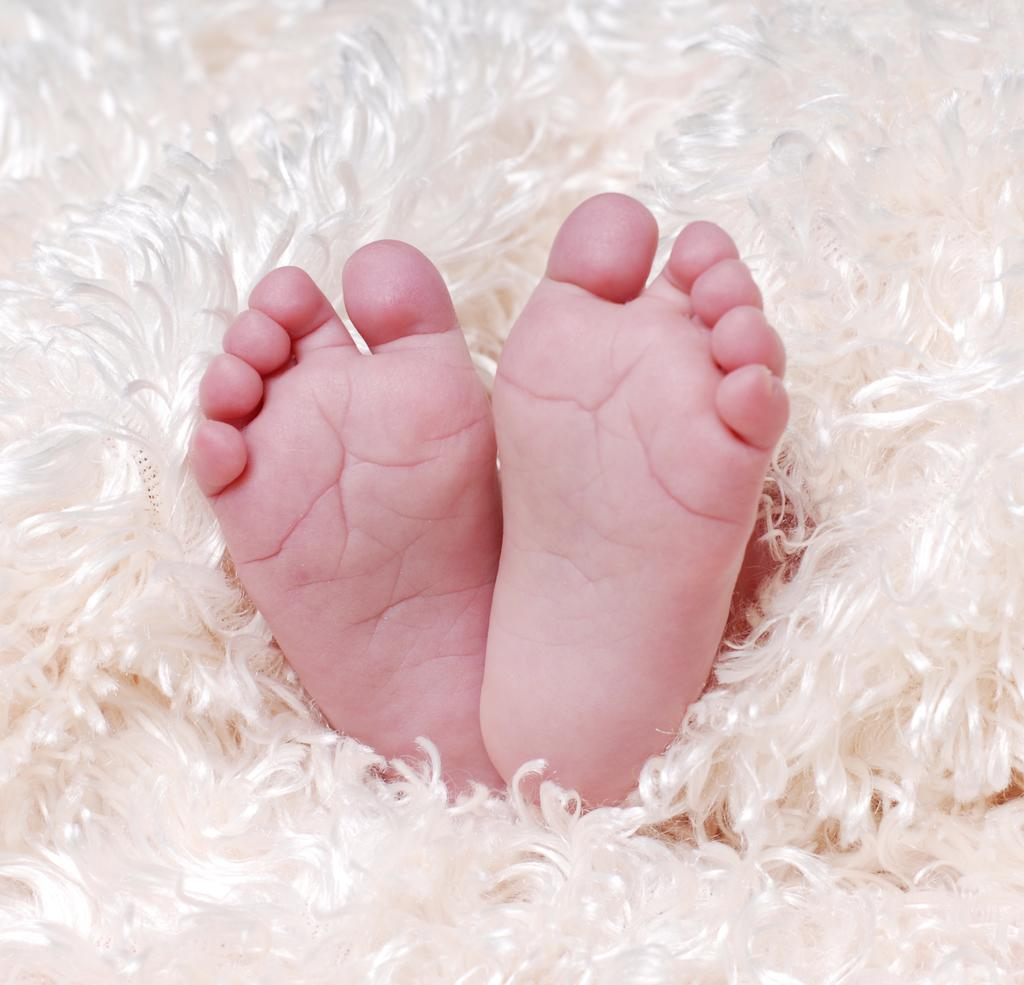What is the main subject of the picture? The main subject of the picture is an infant. What part of the infant's body is visible in the image? The infant's legs are visible in the image. What color are the infant's legs? The infant's legs are in pink color. What is the infant's legs wrapped around? The infant's legs are wrapped around a white feather blanket. What type of crow can be seen sitting on the snow in the image? There is no crow or snow present in the image; it features an infant with pink legs wrapped around a white feather blanket. 